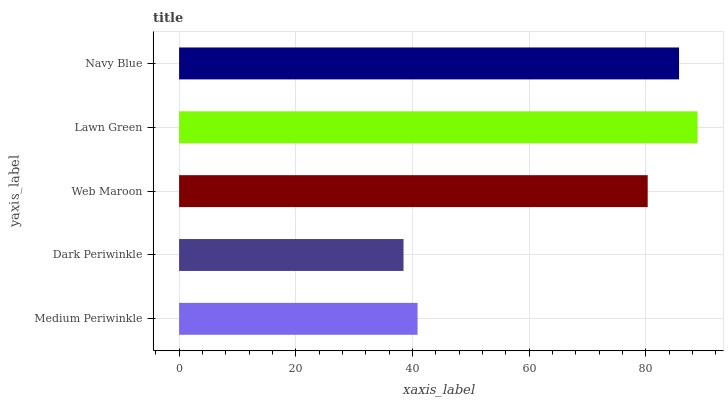Is Dark Periwinkle the minimum?
Answer yes or no. Yes. Is Lawn Green the maximum?
Answer yes or no. Yes. Is Web Maroon the minimum?
Answer yes or no. No. Is Web Maroon the maximum?
Answer yes or no. No. Is Web Maroon greater than Dark Periwinkle?
Answer yes or no. Yes. Is Dark Periwinkle less than Web Maroon?
Answer yes or no. Yes. Is Dark Periwinkle greater than Web Maroon?
Answer yes or no. No. Is Web Maroon less than Dark Periwinkle?
Answer yes or no. No. Is Web Maroon the high median?
Answer yes or no. Yes. Is Web Maroon the low median?
Answer yes or no. Yes. Is Lawn Green the high median?
Answer yes or no. No. Is Navy Blue the low median?
Answer yes or no. No. 